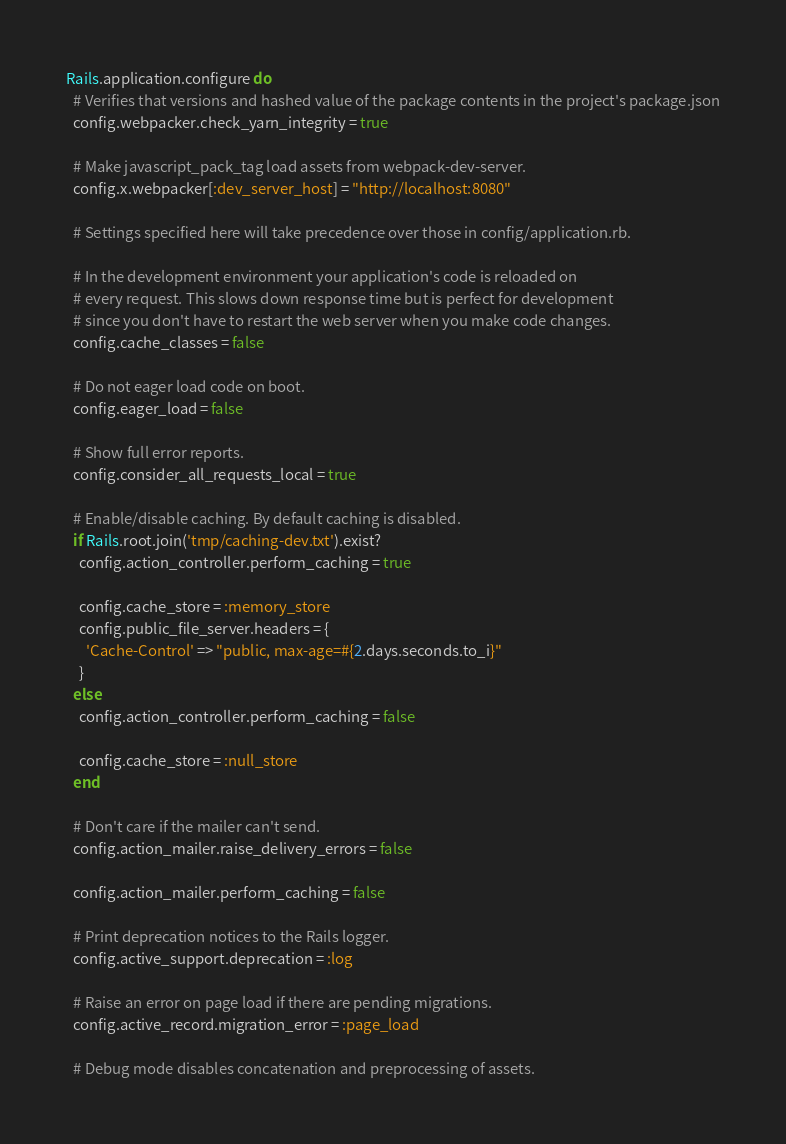Convert code to text. <code><loc_0><loc_0><loc_500><loc_500><_Ruby_>Rails.application.configure do
  # Verifies that versions and hashed value of the package contents in the project's package.json
  config.webpacker.check_yarn_integrity = true

  # Make javascript_pack_tag load assets from webpack-dev-server.
  config.x.webpacker[:dev_server_host] = "http://localhost:8080"

  # Settings specified here will take precedence over those in config/application.rb.

  # In the development environment your application's code is reloaded on
  # every request. This slows down response time but is perfect for development
  # since you don't have to restart the web server when you make code changes.
  config.cache_classes = false

  # Do not eager load code on boot.
  config.eager_load = false

  # Show full error reports.
  config.consider_all_requests_local = true

  # Enable/disable caching. By default caching is disabled.
  if Rails.root.join('tmp/caching-dev.txt').exist?
    config.action_controller.perform_caching = true

    config.cache_store = :memory_store
    config.public_file_server.headers = {
      'Cache-Control' => "public, max-age=#{2.days.seconds.to_i}"
    }
  else
    config.action_controller.perform_caching = false

    config.cache_store = :null_store
  end

  # Don't care if the mailer can't send.
  config.action_mailer.raise_delivery_errors = false

  config.action_mailer.perform_caching = false

  # Print deprecation notices to the Rails logger.
  config.active_support.deprecation = :log

  # Raise an error on page load if there are pending migrations.
  config.active_record.migration_error = :page_load

  # Debug mode disables concatenation and preprocessing of assets.</code> 